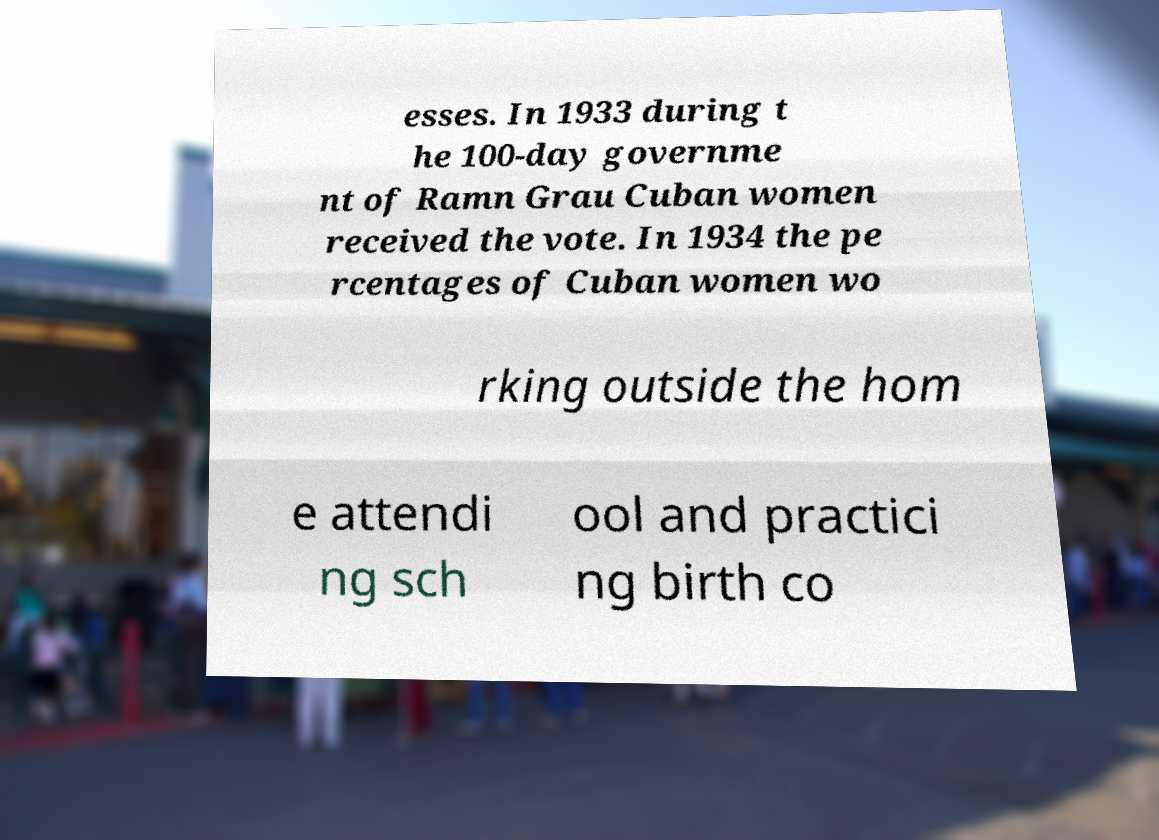What messages or text are displayed in this image? I need them in a readable, typed format. esses. In 1933 during t he 100-day governme nt of Ramn Grau Cuban women received the vote. In 1934 the pe rcentages of Cuban women wo rking outside the hom e attendi ng sch ool and practici ng birth co 